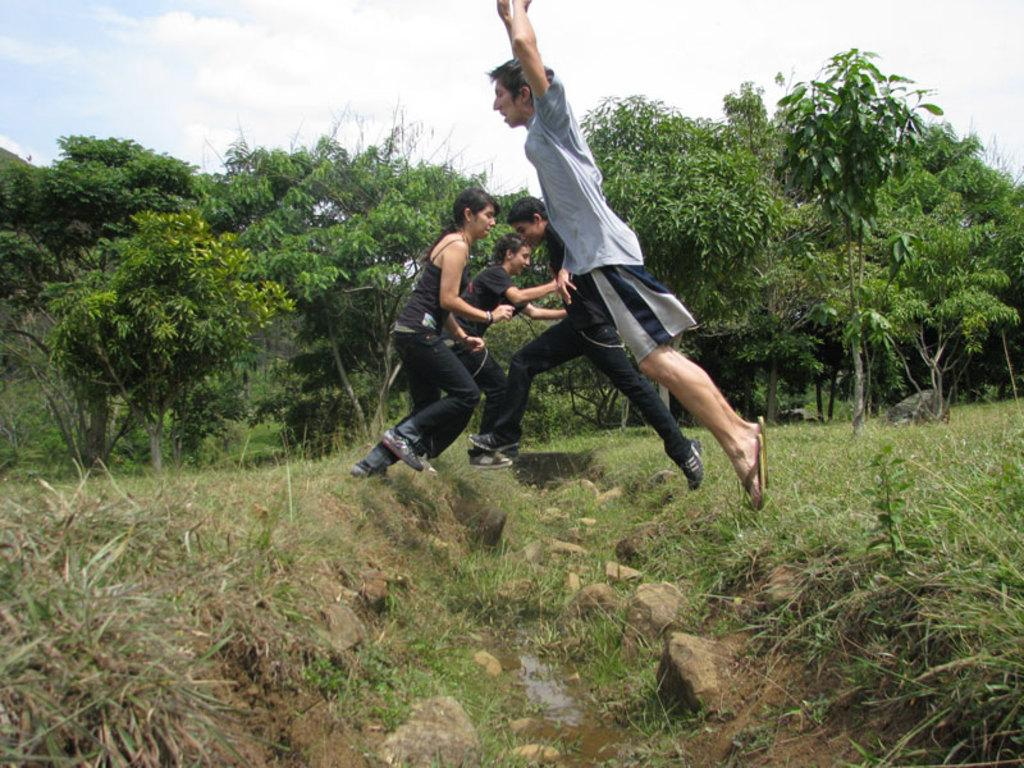What type of vegetation can be seen in the image? There are trees, plants, and grass in the image. How many people are present in the image? There are four persons in the image. What are the persons wearing? The persons are wearing clothes. What is visible in the sky in the image? There are clouds in the sky. Can you see any planes flying in the image? There are no planes visible in the image. What type of fang can be seen on the person in the image? There are no fangs present in the image, and the people are wearing regular clothes. 